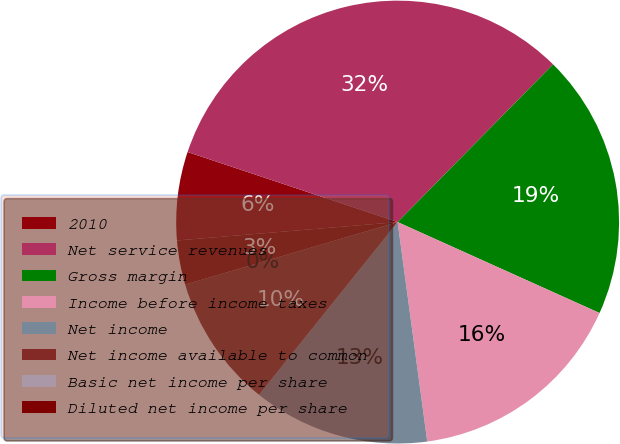<chart> <loc_0><loc_0><loc_500><loc_500><pie_chart><fcel>2010<fcel>Net service revenues<fcel>Gross margin<fcel>Income before income taxes<fcel>Net income<fcel>Net income available to common<fcel>Basic net income per share<fcel>Diluted net income per share<nl><fcel>6.45%<fcel>32.26%<fcel>19.35%<fcel>16.13%<fcel>12.9%<fcel>9.68%<fcel>0.0%<fcel>3.23%<nl></chart> 